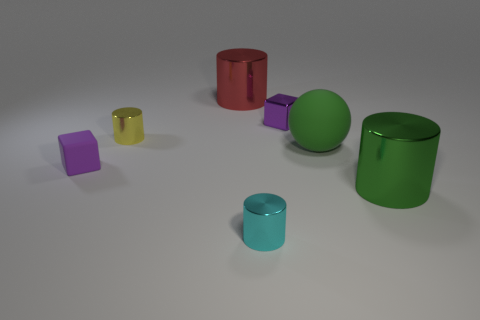There is a red thing that is the same shape as the big green metallic object; what is its material?
Your answer should be very brief. Metal. Does the metal cylinder that is on the left side of the red thing have the same size as the large green cylinder?
Provide a short and direct response. No. There is a red metal thing; how many yellow objects are to the right of it?
Your answer should be compact. 0. Is the number of cyan shiny cylinders behind the yellow cylinder less than the number of purple rubber things that are to the left of the red shiny cylinder?
Your response must be concise. Yes. What number of small blocks are there?
Your answer should be very brief. 2. What color is the big shiny thing behind the tiny matte block?
Your answer should be compact. Red. The green cylinder is what size?
Keep it short and to the point. Large. There is a rubber cube; does it have the same color as the cube on the right side of the small yellow metallic thing?
Your response must be concise. Yes. There is a large cylinder that is behind the tiny purple object in front of the matte sphere; what is its color?
Provide a succinct answer. Red. There is a large red object that is behind the tiny yellow metallic cylinder; is it the same shape as the tiny yellow shiny thing?
Offer a terse response. Yes. 